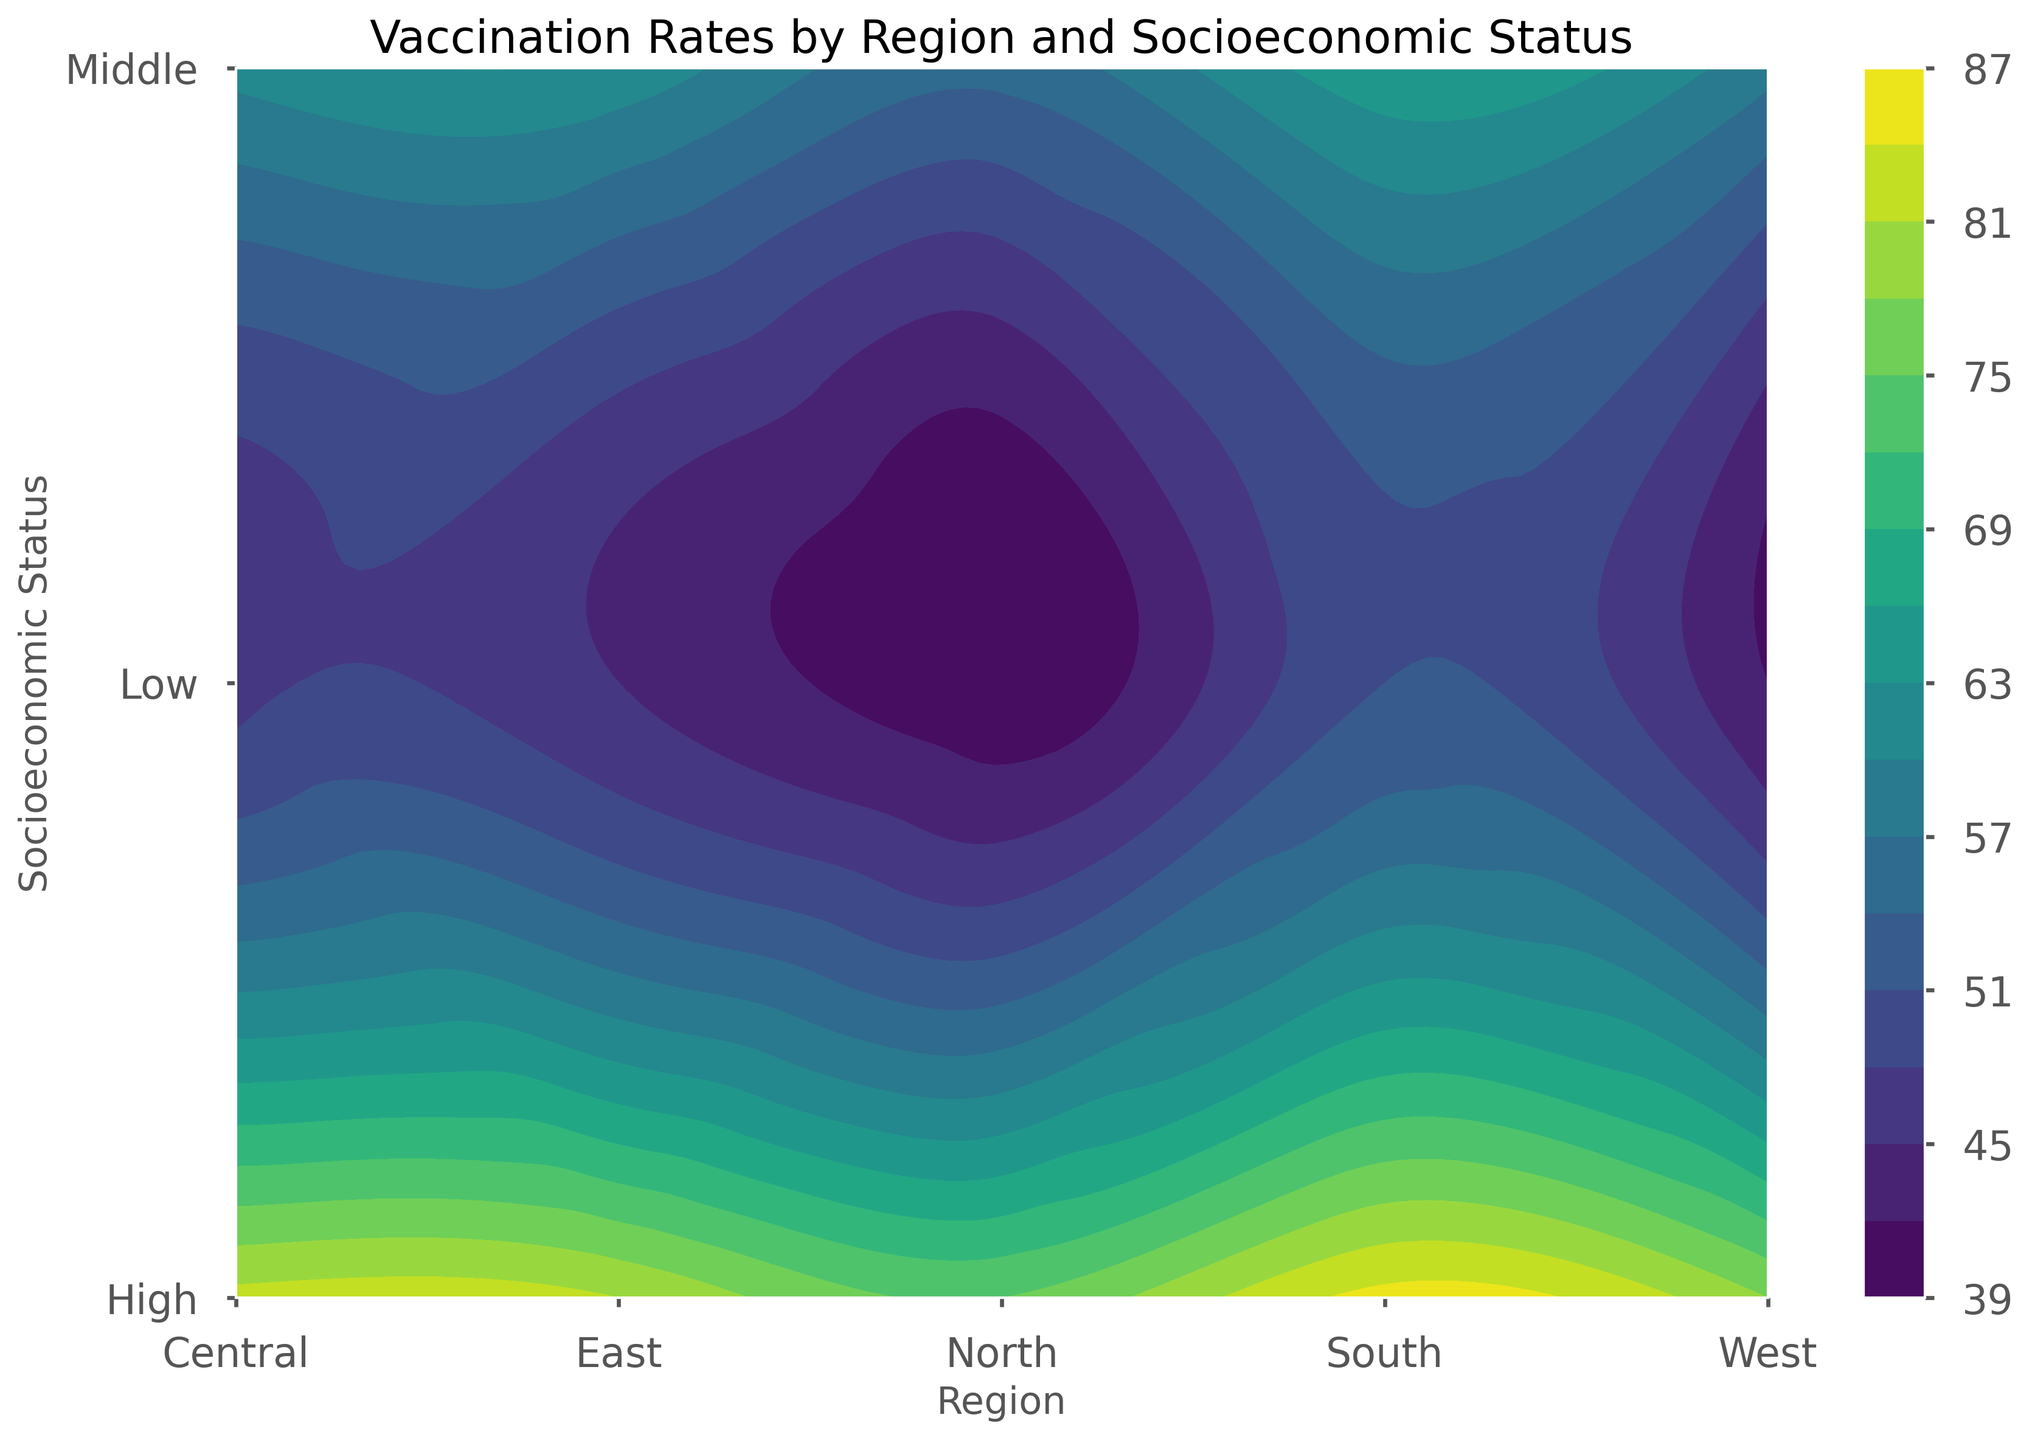What region has the highest vaccination rate for high socioeconomic status? Look at the contour plot, find the section representing high socioeconomic status, and identify the region with the darkest shading, which indicates the highest vaccination rate.
Answer: South What is the difference between the vaccination rates for low socioeconomic status in the North and the West? Locate the contour levels for low socioeconomic status in both the North and the West regions. Subtract the vaccination rate of the West from that of the North.
Answer: 40 - 42 = -2 Which region shows the steepest increase in vaccination rates from low to high socioeconomic status? Compare the contour gradients between low and high socioeconomic statuses across all regions. The region with the steepest gradient is the one with the greatest change in color shades.
Answer: South Does the Central region have a higher vaccination rate for middle socioeconomic status compared to the East? Check the contour levels corresponding to middle socioeconomic status in both the Central and East regions and compare their respective vaccination rates.
Answer: Yes What is the average vaccination rate for middle socioeconomic status across all regions? Identify the vaccination rates for the middle socioeconomic status in each region (North, East, South, West, Central) and calculate their average.
Answer: (55 + 60 + 65 + 58 + 61) / 5 = 59.8 Among all regions, which has the lowest vaccination rate for low socioeconomic status and what is this rate? Examine the contour for low socioeconomic status in all regions and find the region with the lightest shade, indicating the lowest rate.
Answer: North, 39 Is there any region where the high socioeconomic group has a vaccination rate above 85? Look at the contour segment for high socioeconomic status in each region to see if any region's rate exceeds 85.
Answer: Yes, South How do vaccination rates in the East for high socioeconomic status compare to those in the West for the same status? Compare the contour levels for high socioeconomic status in both the East and the West and see which is higher.
Answer: East is slightly lower than West What is the trend in vaccination rates as socioeconomic status increases in the Central region? Observe the contour gradient in the Central region from low to high socioeconomic status and note how the shade changes.
Answer: Increasing trend Which region shows the least variation in vaccination rates across different socioeconomic statuses? Compare the contour gradients for all regions. The region with the least gradient indicates the least variation.
Answer: West 